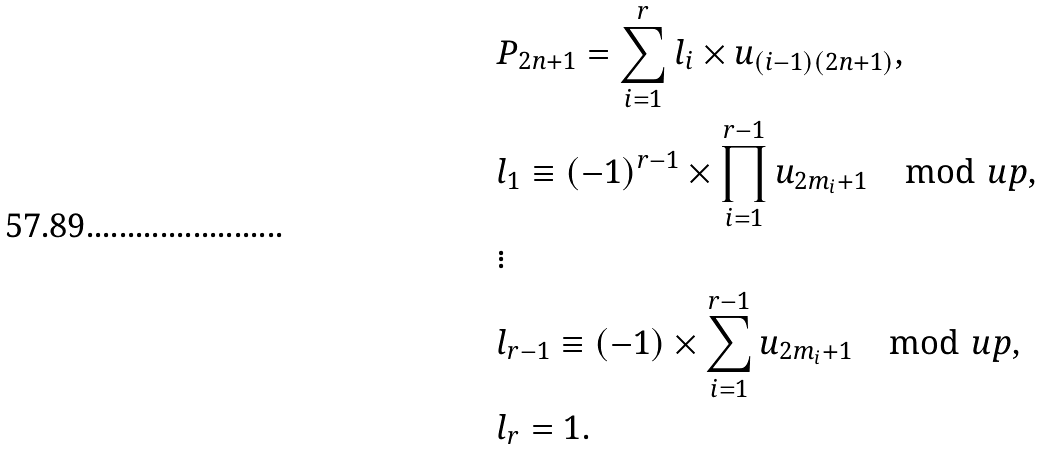<formula> <loc_0><loc_0><loc_500><loc_500>& P _ { 2 n + 1 } = \sum _ { i = 1 } ^ { r } l _ { i } \times u _ { ( i - 1 ) ( 2 n + 1 ) } , \\ & l _ { 1 } \equiv ( - 1 ) ^ { r - 1 } \times \prod _ { i = 1 } ^ { r - 1 } u _ { 2 m _ { i } + 1 } \mod u p , \\ & \vdots \\ & l _ { r - 1 } \equiv ( - 1 ) \times \sum _ { i = 1 } ^ { r - 1 } u _ { 2 m _ { i } + 1 } \mod u p , \\ & l _ { r } = 1 .</formula> 